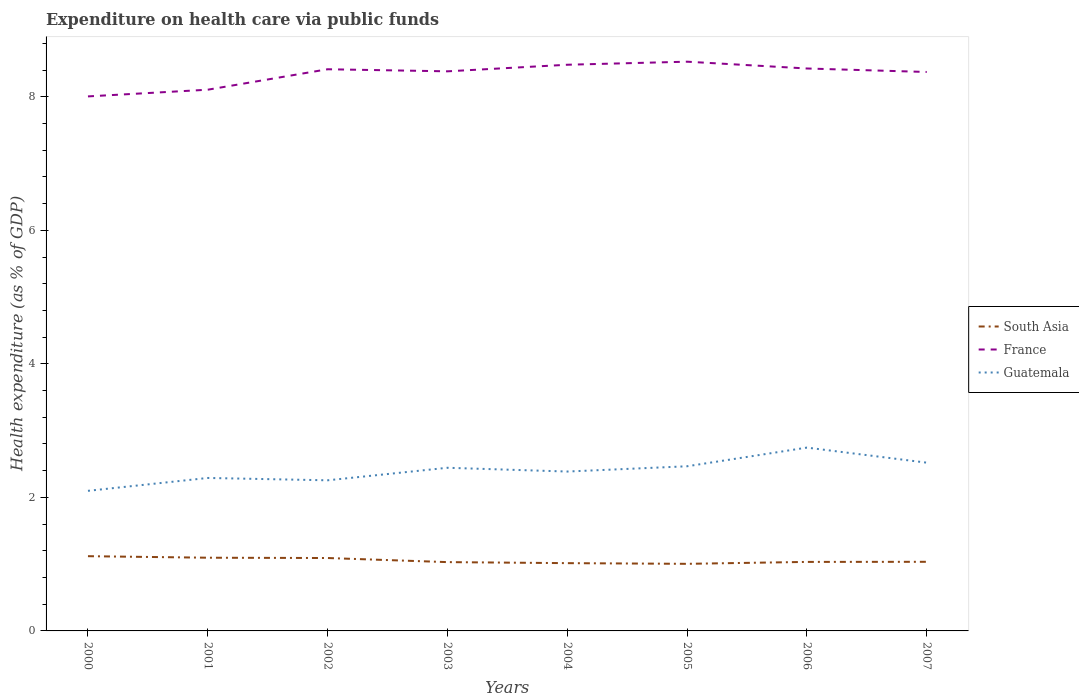How many different coloured lines are there?
Make the answer very short. 3. Is the number of lines equal to the number of legend labels?
Make the answer very short. Yes. Across all years, what is the maximum expenditure made on health care in South Asia?
Offer a terse response. 1. What is the total expenditure made on health care in South Asia in the graph?
Provide a short and direct response. 0.06. What is the difference between the highest and the second highest expenditure made on health care in South Asia?
Offer a very short reply. 0.11. What is the difference between two consecutive major ticks on the Y-axis?
Keep it short and to the point. 2. Where does the legend appear in the graph?
Give a very brief answer. Center right. What is the title of the graph?
Provide a succinct answer. Expenditure on health care via public funds. Does "Niger" appear as one of the legend labels in the graph?
Ensure brevity in your answer.  No. What is the label or title of the X-axis?
Your response must be concise. Years. What is the label or title of the Y-axis?
Your response must be concise. Health expenditure (as % of GDP). What is the Health expenditure (as % of GDP) of South Asia in 2000?
Ensure brevity in your answer.  1.12. What is the Health expenditure (as % of GDP) of France in 2000?
Make the answer very short. 8.01. What is the Health expenditure (as % of GDP) in Guatemala in 2000?
Offer a very short reply. 2.1. What is the Health expenditure (as % of GDP) of South Asia in 2001?
Provide a short and direct response. 1.1. What is the Health expenditure (as % of GDP) in France in 2001?
Your answer should be compact. 8.11. What is the Health expenditure (as % of GDP) of Guatemala in 2001?
Offer a very short reply. 2.29. What is the Health expenditure (as % of GDP) in South Asia in 2002?
Provide a succinct answer. 1.09. What is the Health expenditure (as % of GDP) of France in 2002?
Provide a short and direct response. 8.41. What is the Health expenditure (as % of GDP) of Guatemala in 2002?
Keep it short and to the point. 2.26. What is the Health expenditure (as % of GDP) of South Asia in 2003?
Your answer should be very brief. 1.03. What is the Health expenditure (as % of GDP) of France in 2003?
Give a very brief answer. 8.38. What is the Health expenditure (as % of GDP) of Guatemala in 2003?
Offer a terse response. 2.44. What is the Health expenditure (as % of GDP) of South Asia in 2004?
Provide a short and direct response. 1.02. What is the Health expenditure (as % of GDP) of France in 2004?
Your response must be concise. 8.48. What is the Health expenditure (as % of GDP) of Guatemala in 2004?
Give a very brief answer. 2.39. What is the Health expenditure (as % of GDP) in South Asia in 2005?
Your answer should be compact. 1. What is the Health expenditure (as % of GDP) in France in 2005?
Make the answer very short. 8.53. What is the Health expenditure (as % of GDP) in Guatemala in 2005?
Keep it short and to the point. 2.47. What is the Health expenditure (as % of GDP) of South Asia in 2006?
Offer a terse response. 1.03. What is the Health expenditure (as % of GDP) in France in 2006?
Your answer should be very brief. 8.42. What is the Health expenditure (as % of GDP) of Guatemala in 2006?
Make the answer very short. 2.75. What is the Health expenditure (as % of GDP) of South Asia in 2007?
Give a very brief answer. 1.04. What is the Health expenditure (as % of GDP) in France in 2007?
Keep it short and to the point. 8.37. What is the Health expenditure (as % of GDP) in Guatemala in 2007?
Make the answer very short. 2.52. Across all years, what is the maximum Health expenditure (as % of GDP) in South Asia?
Provide a succinct answer. 1.12. Across all years, what is the maximum Health expenditure (as % of GDP) in France?
Offer a very short reply. 8.53. Across all years, what is the maximum Health expenditure (as % of GDP) of Guatemala?
Offer a very short reply. 2.75. Across all years, what is the minimum Health expenditure (as % of GDP) in South Asia?
Make the answer very short. 1. Across all years, what is the minimum Health expenditure (as % of GDP) of France?
Give a very brief answer. 8.01. Across all years, what is the minimum Health expenditure (as % of GDP) of Guatemala?
Your answer should be compact. 2.1. What is the total Health expenditure (as % of GDP) in South Asia in the graph?
Give a very brief answer. 8.43. What is the total Health expenditure (as % of GDP) of France in the graph?
Give a very brief answer. 66.71. What is the total Health expenditure (as % of GDP) in Guatemala in the graph?
Your answer should be very brief. 19.21. What is the difference between the Health expenditure (as % of GDP) of South Asia in 2000 and that in 2001?
Make the answer very short. 0.02. What is the difference between the Health expenditure (as % of GDP) in France in 2000 and that in 2001?
Offer a very short reply. -0.1. What is the difference between the Health expenditure (as % of GDP) of Guatemala in 2000 and that in 2001?
Keep it short and to the point. -0.19. What is the difference between the Health expenditure (as % of GDP) of South Asia in 2000 and that in 2002?
Offer a very short reply. 0.03. What is the difference between the Health expenditure (as % of GDP) of France in 2000 and that in 2002?
Your answer should be very brief. -0.41. What is the difference between the Health expenditure (as % of GDP) of Guatemala in 2000 and that in 2002?
Offer a very short reply. -0.16. What is the difference between the Health expenditure (as % of GDP) of South Asia in 2000 and that in 2003?
Provide a short and direct response. 0.09. What is the difference between the Health expenditure (as % of GDP) of France in 2000 and that in 2003?
Offer a very short reply. -0.38. What is the difference between the Health expenditure (as % of GDP) in Guatemala in 2000 and that in 2003?
Offer a very short reply. -0.35. What is the difference between the Health expenditure (as % of GDP) of South Asia in 2000 and that in 2004?
Make the answer very short. 0.1. What is the difference between the Health expenditure (as % of GDP) of France in 2000 and that in 2004?
Offer a terse response. -0.47. What is the difference between the Health expenditure (as % of GDP) of Guatemala in 2000 and that in 2004?
Offer a terse response. -0.29. What is the difference between the Health expenditure (as % of GDP) of South Asia in 2000 and that in 2005?
Give a very brief answer. 0.11. What is the difference between the Health expenditure (as % of GDP) in France in 2000 and that in 2005?
Provide a succinct answer. -0.52. What is the difference between the Health expenditure (as % of GDP) in Guatemala in 2000 and that in 2005?
Give a very brief answer. -0.37. What is the difference between the Health expenditure (as % of GDP) in South Asia in 2000 and that in 2006?
Your answer should be compact. 0.09. What is the difference between the Health expenditure (as % of GDP) in France in 2000 and that in 2006?
Your answer should be compact. -0.42. What is the difference between the Health expenditure (as % of GDP) in Guatemala in 2000 and that in 2006?
Offer a very short reply. -0.65. What is the difference between the Health expenditure (as % of GDP) of South Asia in 2000 and that in 2007?
Keep it short and to the point. 0.08. What is the difference between the Health expenditure (as % of GDP) of France in 2000 and that in 2007?
Your response must be concise. -0.37. What is the difference between the Health expenditure (as % of GDP) of Guatemala in 2000 and that in 2007?
Your answer should be very brief. -0.42. What is the difference between the Health expenditure (as % of GDP) in South Asia in 2001 and that in 2002?
Your answer should be compact. 0. What is the difference between the Health expenditure (as % of GDP) of France in 2001 and that in 2002?
Ensure brevity in your answer.  -0.31. What is the difference between the Health expenditure (as % of GDP) of Guatemala in 2001 and that in 2002?
Offer a very short reply. 0.04. What is the difference between the Health expenditure (as % of GDP) of South Asia in 2001 and that in 2003?
Your response must be concise. 0.07. What is the difference between the Health expenditure (as % of GDP) in France in 2001 and that in 2003?
Keep it short and to the point. -0.28. What is the difference between the Health expenditure (as % of GDP) in Guatemala in 2001 and that in 2003?
Provide a short and direct response. -0.15. What is the difference between the Health expenditure (as % of GDP) of South Asia in 2001 and that in 2004?
Your response must be concise. 0.08. What is the difference between the Health expenditure (as % of GDP) in France in 2001 and that in 2004?
Offer a very short reply. -0.37. What is the difference between the Health expenditure (as % of GDP) of Guatemala in 2001 and that in 2004?
Your answer should be very brief. -0.1. What is the difference between the Health expenditure (as % of GDP) in South Asia in 2001 and that in 2005?
Offer a terse response. 0.09. What is the difference between the Health expenditure (as % of GDP) in France in 2001 and that in 2005?
Keep it short and to the point. -0.42. What is the difference between the Health expenditure (as % of GDP) in Guatemala in 2001 and that in 2005?
Offer a terse response. -0.17. What is the difference between the Health expenditure (as % of GDP) of South Asia in 2001 and that in 2006?
Offer a very short reply. 0.06. What is the difference between the Health expenditure (as % of GDP) of France in 2001 and that in 2006?
Offer a terse response. -0.32. What is the difference between the Health expenditure (as % of GDP) in Guatemala in 2001 and that in 2006?
Provide a short and direct response. -0.45. What is the difference between the Health expenditure (as % of GDP) of South Asia in 2001 and that in 2007?
Make the answer very short. 0.06. What is the difference between the Health expenditure (as % of GDP) in France in 2001 and that in 2007?
Offer a terse response. -0.27. What is the difference between the Health expenditure (as % of GDP) of Guatemala in 2001 and that in 2007?
Your response must be concise. -0.23. What is the difference between the Health expenditure (as % of GDP) in South Asia in 2002 and that in 2003?
Offer a terse response. 0.06. What is the difference between the Health expenditure (as % of GDP) of France in 2002 and that in 2003?
Your answer should be compact. 0.03. What is the difference between the Health expenditure (as % of GDP) of Guatemala in 2002 and that in 2003?
Ensure brevity in your answer.  -0.19. What is the difference between the Health expenditure (as % of GDP) of South Asia in 2002 and that in 2004?
Make the answer very short. 0.08. What is the difference between the Health expenditure (as % of GDP) of France in 2002 and that in 2004?
Your answer should be very brief. -0.07. What is the difference between the Health expenditure (as % of GDP) of Guatemala in 2002 and that in 2004?
Keep it short and to the point. -0.13. What is the difference between the Health expenditure (as % of GDP) of South Asia in 2002 and that in 2005?
Make the answer very short. 0.09. What is the difference between the Health expenditure (as % of GDP) of France in 2002 and that in 2005?
Your answer should be very brief. -0.11. What is the difference between the Health expenditure (as % of GDP) in Guatemala in 2002 and that in 2005?
Provide a succinct answer. -0.21. What is the difference between the Health expenditure (as % of GDP) of South Asia in 2002 and that in 2006?
Your answer should be very brief. 0.06. What is the difference between the Health expenditure (as % of GDP) in France in 2002 and that in 2006?
Make the answer very short. -0.01. What is the difference between the Health expenditure (as % of GDP) in Guatemala in 2002 and that in 2006?
Keep it short and to the point. -0.49. What is the difference between the Health expenditure (as % of GDP) of South Asia in 2002 and that in 2007?
Make the answer very short. 0.06. What is the difference between the Health expenditure (as % of GDP) in France in 2002 and that in 2007?
Your response must be concise. 0.04. What is the difference between the Health expenditure (as % of GDP) in Guatemala in 2002 and that in 2007?
Provide a succinct answer. -0.26. What is the difference between the Health expenditure (as % of GDP) of South Asia in 2003 and that in 2004?
Provide a succinct answer. 0.02. What is the difference between the Health expenditure (as % of GDP) in France in 2003 and that in 2004?
Your answer should be very brief. -0.1. What is the difference between the Health expenditure (as % of GDP) of Guatemala in 2003 and that in 2004?
Your response must be concise. 0.06. What is the difference between the Health expenditure (as % of GDP) in South Asia in 2003 and that in 2005?
Your response must be concise. 0.03. What is the difference between the Health expenditure (as % of GDP) in France in 2003 and that in 2005?
Offer a very short reply. -0.14. What is the difference between the Health expenditure (as % of GDP) of Guatemala in 2003 and that in 2005?
Your answer should be very brief. -0.02. What is the difference between the Health expenditure (as % of GDP) of South Asia in 2003 and that in 2006?
Make the answer very short. -0. What is the difference between the Health expenditure (as % of GDP) in France in 2003 and that in 2006?
Provide a short and direct response. -0.04. What is the difference between the Health expenditure (as % of GDP) of Guatemala in 2003 and that in 2006?
Make the answer very short. -0.3. What is the difference between the Health expenditure (as % of GDP) in South Asia in 2003 and that in 2007?
Your answer should be compact. -0. What is the difference between the Health expenditure (as % of GDP) of France in 2003 and that in 2007?
Make the answer very short. 0.01. What is the difference between the Health expenditure (as % of GDP) of Guatemala in 2003 and that in 2007?
Your answer should be compact. -0.08. What is the difference between the Health expenditure (as % of GDP) in South Asia in 2004 and that in 2005?
Offer a terse response. 0.01. What is the difference between the Health expenditure (as % of GDP) of France in 2004 and that in 2005?
Your answer should be very brief. -0.05. What is the difference between the Health expenditure (as % of GDP) of Guatemala in 2004 and that in 2005?
Your answer should be compact. -0.08. What is the difference between the Health expenditure (as % of GDP) in South Asia in 2004 and that in 2006?
Give a very brief answer. -0.02. What is the difference between the Health expenditure (as % of GDP) in France in 2004 and that in 2006?
Offer a terse response. 0.06. What is the difference between the Health expenditure (as % of GDP) in Guatemala in 2004 and that in 2006?
Your response must be concise. -0.36. What is the difference between the Health expenditure (as % of GDP) of South Asia in 2004 and that in 2007?
Provide a short and direct response. -0.02. What is the difference between the Health expenditure (as % of GDP) of France in 2004 and that in 2007?
Your answer should be compact. 0.11. What is the difference between the Health expenditure (as % of GDP) of Guatemala in 2004 and that in 2007?
Keep it short and to the point. -0.13. What is the difference between the Health expenditure (as % of GDP) of South Asia in 2005 and that in 2006?
Offer a very short reply. -0.03. What is the difference between the Health expenditure (as % of GDP) of France in 2005 and that in 2006?
Ensure brevity in your answer.  0.1. What is the difference between the Health expenditure (as % of GDP) of Guatemala in 2005 and that in 2006?
Offer a terse response. -0.28. What is the difference between the Health expenditure (as % of GDP) in South Asia in 2005 and that in 2007?
Provide a succinct answer. -0.03. What is the difference between the Health expenditure (as % of GDP) of France in 2005 and that in 2007?
Make the answer very short. 0.15. What is the difference between the Health expenditure (as % of GDP) of Guatemala in 2005 and that in 2007?
Your response must be concise. -0.05. What is the difference between the Health expenditure (as % of GDP) of South Asia in 2006 and that in 2007?
Offer a very short reply. -0. What is the difference between the Health expenditure (as % of GDP) in France in 2006 and that in 2007?
Provide a short and direct response. 0.05. What is the difference between the Health expenditure (as % of GDP) of Guatemala in 2006 and that in 2007?
Ensure brevity in your answer.  0.23. What is the difference between the Health expenditure (as % of GDP) of South Asia in 2000 and the Health expenditure (as % of GDP) of France in 2001?
Give a very brief answer. -6.99. What is the difference between the Health expenditure (as % of GDP) of South Asia in 2000 and the Health expenditure (as % of GDP) of Guatemala in 2001?
Your answer should be compact. -1.17. What is the difference between the Health expenditure (as % of GDP) in France in 2000 and the Health expenditure (as % of GDP) in Guatemala in 2001?
Provide a short and direct response. 5.71. What is the difference between the Health expenditure (as % of GDP) in South Asia in 2000 and the Health expenditure (as % of GDP) in France in 2002?
Keep it short and to the point. -7.29. What is the difference between the Health expenditure (as % of GDP) in South Asia in 2000 and the Health expenditure (as % of GDP) in Guatemala in 2002?
Your response must be concise. -1.14. What is the difference between the Health expenditure (as % of GDP) in France in 2000 and the Health expenditure (as % of GDP) in Guatemala in 2002?
Make the answer very short. 5.75. What is the difference between the Health expenditure (as % of GDP) of South Asia in 2000 and the Health expenditure (as % of GDP) of France in 2003?
Your answer should be compact. -7.26. What is the difference between the Health expenditure (as % of GDP) of South Asia in 2000 and the Health expenditure (as % of GDP) of Guatemala in 2003?
Provide a succinct answer. -1.32. What is the difference between the Health expenditure (as % of GDP) in France in 2000 and the Health expenditure (as % of GDP) in Guatemala in 2003?
Make the answer very short. 5.56. What is the difference between the Health expenditure (as % of GDP) in South Asia in 2000 and the Health expenditure (as % of GDP) in France in 2004?
Your answer should be very brief. -7.36. What is the difference between the Health expenditure (as % of GDP) of South Asia in 2000 and the Health expenditure (as % of GDP) of Guatemala in 2004?
Offer a terse response. -1.27. What is the difference between the Health expenditure (as % of GDP) in France in 2000 and the Health expenditure (as % of GDP) in Guatemala in 2004?
Keep it short and to the point. 5.62. What is the difference between the Health expenditure (as % of GDP) in South Asia in 2000 and the Health expenditure (as % of GDP) in France in 2005?
Offer a very short reply. -7.41. What is the difference between the Health expenditure (as % of GDP) in South Asia in 2000 and the Health expenditure (as % of GDP) in Guatemala in 2005?
Provide a short and direct response. -1.35. What is the difference between the Health expenditure (as % of GDP) in France in 2000 and the Health expenditure (as % of GDP) in Guatemala in 2005?
Your answer should be very brief. 5.54. What is the difference between the Health expenditure (as % of GDP) of South Asia in 2000 and the Health expenditure (as % of GDP) of France in 2006?
Offer a terse response. -7.3. What is the difference between the Health expenditure (as % of GDP) of South Asia in 2000 and the Health expenditure (as % of GDP) of Guatemala in 2006?
Keep it short and to the point. -1.63. What is the difference between the Health expenditure (as % of GDP) of France in 2000 and the Health expenditure (as % of GDP) of Guatemala in 2006?
Your answer should be compact. 5.26. What is the difference between the Health expenditure (as % of GDP) in South Asia in 2000 and the Health expenditure (as % of GDP) in France in 2007?
Your answer should be compact. -7.25. What is the difference between the Health expenditure (as % of GDP) in South Asia in 2000 and the Health expenditure (as % of GDP) in Guatemala in 2007?
Make the answer very short. -1.4. What is the difference between the Health expenditure (as % of GDP) of France in 2000 and the Health expenditure (as % of GDP) of Guatemala in 2007?
Provide a succinct answer. 5.49. What is the difference between the Health expenditure (as % of GDP) in South Asia in 2001 and the Health expenditure (as % of GDP) in France in 2002?
Keep it short and to the point. -7.32. What is the difference between the Health expenditure (as % of GDP) in South Asia in 2001 and the Health expenditure (as % of GDP) in Guatemala in 2002?
Offer a very short reply. -1.16. What is the difference between the Health expenditure (as % of GDP) in France in 2001 and the Health expenditure (as % of GDP) in Guatemala in 2002?
Your answer should be compact. 5.85. What is the difference between the Health expenditure (as % of GDP) of South Asia in 2001 and the Health expenditure (as % of GDP) of France in 2003?
Your response must be concise. -7.28. What is the difference between the Health expenditure (as % of GDP) of South Asia in 2001 and the Health expenditure (as % of GDP) of Guatemala in 2003?
Offer a very short reply. -1.35. What is the difference between the Health expenditure (as % of GDP) in France in 2001 and the Health expenditure (as % of GDP) in Guatemala in 2003?
Make the answer very short. 5.66. What is the difference between the Health expenditure (as % of GDP) of South Asia in 2001 and the Health expenditure (as % of GDP) of France in 2004?
Offer a terse response. -7.38. What is the difference between the Health expenditure (as % of GDP) of South Asia in 2001 and the Health expenditure (as % of GDP) of Guatemala in 2004?
Your response must be concise. -1.29. What is the difference between the Health expenditure (as % of GDP) of France in 2001 and the Health expenditure (as % of GDP) of Guatemala in 2004?
Your answer should be compact. 5.72. What is the difference between the Health expenditure (as % of GDP) in South Asia in 2001 and the Health expenditure (as % of GDP) in France in 2005?
Ensure brevity in your answer.  -7.43. What is the difference between the Health expenditure (as % of GDP) of South Asia in 2001 and the Health expenditure (as % of GDP) of Guatemala in 2005?
Your answer should be very brief. -1.37. What is the difference between the Health expenditure (as % of GDP) in France in 2001 and the Health expenditure (as % of GDP) in Guatemala in 2005?
Offer a very short reply. 5.64. What is the difference between the Health expenditure (as % of GDP) of South Asia in 2001 and the Health expenditure (as % of GDP) of France in 2006?
Your answer should be compact. -7.33. What is the difference between the Health expenditure (as % of GDP) of South Asia in 2001 and the Health expenditure (as % of GDP) of Guatemala in 2006?
Offer a very short reply. -1.65. What is the difference between the Health expenditure (as % of GDP) of France in 2001 and the Health expenditure (as % of GDP) of Guatemala in 2006?
Make the answer very short. 5.36. What is the difference between the Health expenditure (as % of GDP) of South Asia in 2001 and the Health expenditure (as % of GDP) of France in 2007?
Your answer should be compact. -7.28. What is the difference between the Health expenditure (as % of GDP) of South Asia in 2001 and the Health expenditure (as % of GDP) of Guatemala in 2007?
Your answer should be compact. -1.42. What is the difference between the Health expenditure (as % of GDP) in France in 2001 and the Health expenditure (as % of GDP) in Guatemala in 2007?
Offer a terse response. 5.59. What is the difference between the Health expenditure (as % of GDP) of South Asia in 2002 and the Health expenditure (as % of GDP) of France in 2003?
Provide a short and direct response. -7.29. What is the difference between the Health expenditure (as % of GDP) of South Asia in 2002 and the Health expenditure (as % of GDP) of Guatemala in 2003?
Your answer should be compact. -1.35. What is the difference between the Health expenditure (as % of GDP) of France in 2002 and the Health expenditure (as % of GDP) of Guatemala in 2003?
Offer a terse response. 5.97. What is the difference between the Health expenditure (as % of GDP) of South Asia in 2002 and the Health expenditure (as % of GDP) of France in 2004?
Offer a very short reply. -7.39. What is the difference between the Health expenditure (as % of GDP) of South Asia in 2002 and the Health expenditure (as % of GDP) of Guatemala in 2004?
Make the answer very short. -1.3. What is the difference between the Health expenditure (as % of GDP) in France in 2002 and the Health expenditure (as % of GDP) in Guatemala in 2004?
Provide a short and direct response. 6.03. What is the difference between the Health expenditure (as % of GDP) in South Asia in 2002 and the Health expenditure (as % of GDP) in France in 2005?
Your response must be concise. -7.43. What is the difference between the Health expenditure (as % of GDP) of South Asia in 2002 and the Health expenditure (as % of GDP) of Guatemala in 2005?
Ensure brevity in your answer.  -1.37. What is the difference between the Health expenditure (as % of GDP) of France in 2002 and the Health expenditure (as % of GDP) of Guatemala in 2005?
Give a very brief answer. 5.95. What is the difference between the Health expenditure (as % of GDP) in South Asia in 2002 and the Health expenditure (as % of GDP) in France in 2006?
Provide a short and direct response. -7.33. What is the difference between the Health expenditure (as % of GDP) in South Asia in 2002 and the Health expenditure (as % of GDP) in Guatemala in 2006?
Your answer should be compact. -1.65. What is the difference between the Health expenditure (as % of GDP) in France in 2002 and the Health expenditure (as % of GDP) in Guatemala in 2006?
Provide a succinct answer. 5.67. What is the difference between the Health expenditure (as % of GDP) in South Asia in 2002 and the Health expenditure (as % of GDP) in France in 2007?
Your answer should be very brief. -7.28. What is the difference between the Health expenditure (as % of GDP) of South Asia in 2002 and the Health expenditure (as % of GDP) of Guatemala in 2007?
Your answer should be compact. -1.43. What is the difference between the Health expenditure (as % of GDP) of France in 2002 and the Health expenditure (as % of GDP) of Guatemala in 2007?
Give a very brief answer. 5.89. What is the difference between the Health expenditure (as % of GDP) of South Asia in 2003 and the Health expenditure (as % of GDP) of France in 2004?
Offer a terse response. -7.45. What is the difference between the Health expenditure (as % of GDP) of South Asia in 2003 and the Health expenditure (as % of GDP) of Guatemala in 2004?
Ensure brevity in your answer.  -1.36. What is the difference between the Health expenditure (as % of GDP) in France in 2003 and the Health expenditure (as % of GDP) in Guatemala in 2004?
Offer a terse response. 5.99. What is the difference between the Health expenditure (as % of GDP) in South Asia in 2003 and the Health expenditure (as % of GDP) in France in 2005?
Your answer should be very brief. -7.5. What is the difference between the Health expenditure (as % of GDP) in South Asia in 2003 and the Health expenditure (as % of GDP) in Guatemala in 2005?
Your answer should be very brief. -1.44. What is the difference between the Health expenditure (as % of GDP) of France in 2003 and the Health expenditure (as % of GDP) of Guatemala in 2005?
Ensure brevity in your answer.  5.92. What is the difference between the Health expenditure (as % of GDP) in South Asia in 2003 and the Health expenditure (as % of GDP) in France in 2006?
Your answer should be very brief. -7.39. What is the difference between the Health expenditure (as % of GDP) in South Asia in 2003 and the Health expenditure (as % of GDP) in Guatemala in 2006?
Keep it short and to the point. -1.72. What is the difference between the Health expenditure (as % of GDP) in France in 2003 and the Health expenditure (as % of GDP) in Guatemala in 2006?
Make the answer very short. 5.64. What is the difference between the Health expenditure (as % of GDP) in South Asia in 2003 and the Health expenditure (as % of GDP) in France in 2007?
Your answer should be compact. -7.34. What is the difference between the Health expenditure (as % of GDP) of South Asia in 2003 and the Health expenditure (as % of GDP) of Guatemala in 2007?
Your response must be concise. -1.49. What is the difference between the Health expenditure (as % of GDP) of France in 2003 and the Health expenditure (as % of GDP) of Guatemala in 2007?
Offer a very short reply. 5.86. What is the difference between the Health expenditure (as % of GDP) of South Asia in 2004 and the Health expenditure (as % of GDP) of France in 2005?
Give a very brief answer. -7.51. What is the difference between the Health expenditure (as % of GDP) of South Asia in 2004 and the Health expenditure (as % of GDP) of Guatemala in 2005?
Ensure brevity in your answer.  -1.45. What is the difference between the Health expenditure (as % of GDP) in France in 2004 and the Health expenditure (as % of GDP) in Guatemala in 2005?
Provide a succinct answer. 6.01. What is the difference between the Health expenditure (as % of GDP) in South Asia in 2004 and the Health expenditure (as % of GDP) in France in 2006?
Your response must be concise. -7.41. What is the difference between the Health expenditure (as % of GDP) of South Asia in 2004 and the Health expenditure (as % of GDP) of Guatemala in 2006?
Your response must be concise. -1.73. What is the difference between the Health expenditure (as % of GDP) of France in 2004 and the Health expenditure (as % of GDP) of Guatemala in 2006?
Ensure brevity in your answer.  5.73. What is the difference between the Health expenditure (as % of GDP) of South Asia in 2004 and the Health expenditure (as % of GDP) of France in 2007?
Your answer should be very brief. -7.36. What is the difference between the Health expenditure (as % of GDP) in South Asia in 2004 and the Health expenditure (as % of GDP) in Guatemala in 2007?
Your answer should be compact. -1.5. What is the difference between the Health expenditure (as % of GDP) of France in 2004 and the Health expenditure (as % of GDP) of Guatemala in 2007?
Your answer should be very brief. 5.96. What is the difference between the Health expenditure (as % of GDP) in South Asia in 2005 and the Health expenditure (as % of GDP) in France in 2006?
Give a very brief answer. -7.42. What is the difference between the Health expenditure (as % of GDP) in South Asia in 2005 and the Health expenditure (as % of GDP) in Guatemala in 2006?
Keep it short and to the point. -1.74. What is the difference between the Health expenditure (as % of GDP) in France in 2005 and the Health expenditure (as % of GDP) in Guatemala in 2006?
Provide a short and direct response. 5.78. What is the difference between the Health expenditure (as % of GDP) of South Asia in 2005 and the Health expenditure (as % of GDP) of France in 2007?
Your response must be concise. -7.37. What is the difference between the Health expenditure (as % of GDP) of South Asia in 2005 and the Health expenditure (as % of GDP) of Guatemala in 2007?
Your answer should be compact. -1.52. What is the difference between the Health expenditure (as % of GDP) in France in 2005 and the Health expenditure (as % of GDP) in Guatemala in 2007?
Ensure brevity in your answer.  6.01. What is the difference between the Health expenditure (as % of GDP) of South Asia in 2006 and the Health expenditure (as % of GDP) of France in 2007?
Offer a very short reply. -7.34. What is the difference between the Health expenditure (as % of GDP) of South Asia in 2006 and the Health expenditure (as % of GDP) of Guatemala in 2007?
Give a very brief answer. -1.49. What is the difference between the Health expenditure (as % of GDP) of France in 2006 and the Health expenditure (as % of GDP) of Guatemala in 2007?
Offer a very short reply. 5.9. What is the average Health expenditure (as % of GDP) of South Asia per year?
Ensure brevity in your answer.  1.05. What is the average Health expenditure (as % of GDP) of France per year?
Give a very brief answer. 8.34. What is the average Health expenditure (as % of GDP) in Guatemala per year?
Offer a terse response. 2.4. In the year 2000, what is the difference between the Health expenditure (as % of GDP) in South Asia and Health expenditure (as % of GDP) in France?
Make the answer very short. -6.89. In the year 2000, what is the difference between the Health expenditure (as % of GDP) in South Asia and Health expenditure (as % of GDP) in Guatemala?
Keep it short and to the point. -0.98. In the year 2000, what is the difference between the Health expenditure (as % of GDP) in France and Health expenditure (as % of GDP) in Guatemala?
Make the answer very short. 5.91. In the year 2001, what is the difference between the Health expenditure (as % of GDP) of South Asia and Health expenditure (as % of GDP) of France?
Provide a succinct answer. -7.01. In the year 2001, what is the difference between the Health expenditure (as % of GDP) in South Asia and Health expenditure (as % of GDP) in Guatemala?
Provide a succinct answer. -1.19. In the year 2001, what is the difference between the Health expenditure (as % of GDP) in France and Health expenditure (as % of GDP) in Guatemala?
Your response must be concise. 5.82. In the year 2002, what is the difference between the Health expenditure (as % of GDP) in South Asia and Health expenditure (as % of GDP) in France?
Your response must be concise. -7.32. In the year 2002, what is the difference between the Health expenditure (as % of GDP) of South Asia and Health expenditure (as % of GDP) of Guatemala?
Your answer should be very brief. -1.16. In the year 2002, what is the difference between the Health expenditure (as % of GDP) of France and Health expenditure (as % of GDP) of Guatemala?
Your response must be concise. 6.16. In the year 2003, what is the difference between the Health expenditure (as % of GDP) in South Asia and Health expenditure (as % of GDP) in France?
Provide a succinct answer. -7.35. In the year 2003, what is the difference between the Health expenditure (as % of GDP) in South Asia and Health expenditure (as % of GDP) in Guatemala?
Offer a terse response. -1.41. In the year 2003, what is the difference between the Health expenditure (as % of GDP) of France and Health expenditure (as % of GDP) of Guatemala?
Make the answer very short. 5.94. In the year 2004, what is the difference between the Health expenditure (as % of GDP) of South Asia and Health expenditure (as % of GDP) of France?
Your answer should be very brief. -7.46. In the year 2004, what is the difference between the Health expenditure (as % of GDP) of South Asia and Health expenditure (as % of GDP) of Guatemala?
Offer a terse response. -1.37. In the year 2004, what is the difference between the Health expenditure (as % of GDP) of France and Health expenditure (as % of GDP) of Guatemala?
Your answer should be very brief. 6.09. In the year 2005, what is the difference between the Health expenditure (as % of GDP) in South Asia and Health expenditure (as % of GDP) in France?
Give a very brief answer. -7.52. In the year 2005, what is the difference between the Health expenditure (as % of GDP) of South Asia and Health expenditure (as % of GDP) of Guatemala?
Keep it short and to the point. -1.46. In the year 2005, what is the difference between the Health expenditure (as % of GDP) in France and Health expenditure (as % of GDP) in Guatemala?
Keep it short and to the point. 6.06. In the year 2006, what is the difference between the Health expenditure (as % of GDP) of South Asia and Health expenditure (as % of GDP) of France?
Offer a very short reply. -7.39. In the year 2006, what is the difference between the Health expenditure (as % of GDP) in South Asia and Health expenditure (as % of GDP) in Guatemala?
Make the answer very short. -1.71. In the year 2006, what is the difference between the Health expenditure (as % of GDP) of France and Health expenditure (as % of GDP) of Guatemala?
Your answer should be very brief. 5.68. In the year 2007, what is the difference between the Health expenditure (as % of GDP) of South Asia and Health expenditure (as % of GDP) of France?
Give a very brief answer. -7.34. In the year 2007, what is the difference between the Health expenditure (as % of GDP) of South Asia and Health expenditure (as % of GDP) of Guatemala?
Your answer should be very brief. -1.48. In the year 2007, what is the difference between the Health expenditure (as % of GDP) of France and Health expenditure (as % of GDP) of Guatemala?
Your answer should be very brief. 5.85. What is the ratio of the Health expenditure (as % of GDP) of South Asia in 2000 to that in 2001?
Offer a very short reply. 1.02. What is the ratio of the Health expenditure (as % of GDP) in France in 2000 to that in 2001?
Provide a succinct answer. 0.99. What is the ratio of the Health expenditure (as % of GDP) in Guatemala in 2000 to that in 2001?
Offer a very short reply. 0.92. What is the ratio of the Health expenditure (as % of GDP) of South Asia in 2000 to that in 2002?
Your answer should be very brief. 1.03. What is the ratio of the Health expenditure (as % of GDP) in France in 2000 to that in 2002?
Your answer should be compact. 0.95. What is the ratio of the Health expenditure (as % of GDP) of Guatemala in 2000 to that in 2002?
Give a very brief answer. 0.93. What is the ratio of the Health expenditure (as % of GDP) of South Asia in 2000 to that in 2003?
Give a very brief answer. 1.09. What is the ratio of the Health expenditure (as % of GDP) of France in 2000 to that in 2003?
Your answer should be very brief. 0.96. What is the ratio of the Health expenditure (as % of GDP) in Guatemala in 2000 to that in 2003?
Make the answer very short. 0.86. What is the ratio of the Health expenditure (as % of GDP) in South Asia in 2000 to that in 2004?
Your answer should be very brief. 1.1. What is the ratio of the Health expenditure (as % of GDP) in France in 2000 to that in 2004?
Your answer should be compact. 0.94. What is the ratio of the Health expenditure (as % of GDP) of Guatemala in 2000 to that in 2004?
Your answer should be compact. 0.88. What is the ratio of the Health expenditure (as % of GDP) in South Asia in 2000 to that in 2005?
Give a very brief answer. 1.11. What is the ratio of the Health expenditure (as % of GDP) of France in 2000 to that in 2005?
Your answer should be compact. 0.94. What is the ratio of the Health expenditure (as % of GDP) of Guatemala in 2000 to that in 2005?
Your response must be concise. 0.85. What is the ratio of the Health expenditure (as % of GDP) of South Asia in 2000 to that in 2006?
Your answer should be compact. 1.08. What is the ratio of the Health expenditure (as % of GDP) of France in 2000 to that in 2006?
Keep it short and to the point. 0.95. What is the ratio of the Health expenditure (as % of GDP) of Guatemala in 2000 to that in 2006?
Offer a terse response. 0.76. What is the ratio of the Health expenditure (as % of GDP) in South Asia in 2000 to that in 2007?
Offer a terse response. 1.08. What is the ratio of the Health expenditure (as % of GDP) of France in 2000 to that in 2007?
Keep it short and to the point. 0.96. What is the ratio of the Health expenditure (as % of GDP) of Guatemala in 2000 to that in 2007?
Keep it short and to the point. 0.83. What is the ratio of the Health expenditure (as % of GDP) in France in 2001 to that in 2002?
Offer a very short reply. 0.96. What is the ratio of the Health expenditure (as % of GDP) in Guatemala in 2001 to that in 2002?
Provide a short and direct response. 1.02. What is the ratio of the Health expenditure (as % of GDP) of South Asia in 2001 to that in 2003?
Offer a very short reply. 1.06. What is the ratio of the Health expenditure (as % of GDP) of France in 2001 to that in 2003?
Ensure brevity in your answer.  0.97. What is the ratio of the Health expenditure (as % of GDP) in Guatemala in 2001 to that in 2003?
Ensure brevity in your answer.  0.94. What is the ratio of the Health expenditure (as % of GDP) in South Asia in 2001 to that in 2004?
Offer a very short reply. 1.08. What is the ratio of the Health expenditure (as % of GDP) in France in 2001 to that in 2004?
Ensure brevity in your answer.  0.96. What is the ratio of the Health expenditure (as % of GDP) in Guatemala in 2001 to that in 2004?
Provide a short and direct response. 0.96. What is the ratio of the Health expenditure (as % of GDP) in South Asia in 2001 to that in 2005?
Give a very brief answer. 1.09. What is the ratio of the Health expenditure (as % of GDP) in France in 2001 to that in 2005?
Provide a succinct answer. 0.95. What is the ratio of the Health expenditure (as % of GDP) of Guatemala in 2001 to that in 2005?
Give a very brief answer. 0.93. What is the ratio of the Health expenditure (as % of GDP) in South Asia in 2001 to that in 2006?
Offer a terse response. 1.06. What is the ratio of the Health expenditure (as % of GDP) of France in 2001 to that in 2006?
Your answer should be compact. 0.96. What is the ratio of the Health expenditure (as % of GDP) of Guatemala in 2001 to that in 2006?
Offer a terse response. 0.83. What is the ratio of the Health expenditure (as % of GDP) in South Asia in 2001 to that in 2007?
Ensure brevity in your answer.  1.06. What is the ratio of the Health expenditure (as % of GDP) in France in 2001 to that in 2007?
Keep it short and to the point. 0.97. What is the ratio of the Health expenditure (as % of GDP) in South Asia in 2002 to that in 2003?
Provide a short and direct response. 1.06. What is the ratio of the Health expenditure (as % of GDP) in Guatemala in 2002 to that in 2003?
Keep it short and to the point. 0.92. What is the ratio of the Health expenditure (as % of GDP) in South Asia in 2002 to that in 2004?
Your answer should be very brief. 1.08. What is the ratio of the Health expenditure (as % of GDP) of France in 2002 to that in 2004?
Provide a succinct answer. 0.99. What is the ratio of the Health expenditure (as % of GDP) of Guatemala in 2002 to that in 2004?
Offer a terse response. 0.94. What is the ratio of the Health expenditure (as % of GDP) of South Asia in 2002 to that in 2005?
Give a very brief answer. 1.09. What is the ratio of the Health expenditure (as % of GDP) in France in 2002 to that in 2005?
Ensure brevity in your answer.  0.99. What is the ratio of the Health expenditure (as % of GDP) in Guatemala in 2002 to that in 2005?
Your answer should be very brief. 0.91. What is the ratio of the Health expenditure (as % of GDP) in South Asia in 2002 to that in 2006?
Keep it short and to the point. 1.06. What is the ratio of the Health expenditure (as % of GDP) in France in 2002 to that in 2006?
Provide a succinct answer. 1. What is the ratio of the Health expenditure (as % of GDP) of Guatemala in 2002 to that in 2006?
Keep it short and to the point. 0.82. What is the ratio of the Health expenditure (as % of GDP) in South Asia in 2002 to that in 2007?
Keep it short and to the point. 1.05. What is the ratio of the Health expenditure (as % of GDP) in Guatemala in 2002 to that in 2007?
Provide a succinct answer. 0.9. What is the ratio of the Health expenditure (as % of GDP) in South Asia in 2003 to that in 2004?
Ensure brevity in your answer.  1.02. What is the ratio of the Health expenditure (as % of GDP) in France in 2003 to that in 2004?
Provide a succinct answer. 0.99. What is the ratio of the Health expenditure (as % of GDP) of Guatemala in 2003 to that in 2004?
Give a very brief answer. 1.02. What is the ratio of the Health expenditure (as % of GDP) in South Asia in 2003 to that in 2005?
Your answer should be compact. 1.03. What is the ratio of the Health expenditure (as % of GDP) of France in 2003 to that in 2005?
Your answer should be very brief. 0.98. What is the ratio of the Health expenditure (as % of GDP) in Guatemala in 2003 to that in 2005?
Provide a short and direct response. 0.99. What is the ratio of the Health expenditure (as % of GDP) in South Asia in 2003 to that in 2006?
Keep it short and to the point. 1. What is the ratio of the Health expenditure (as % of GDP) of France in 2003 to that in 2006?
Offer a very short reply. 0.99. What is the ratio of the Health expenditure (as % of GDP) of Guatemala in 2003 to that in 2006?
Provide a succinct answer. 0.89. What is the ratio of the Health expenditure (as % of GDP) in France in 2003 to that in 2007?
Provide a succinct answer. 1. What is the ratio of the Health expenditure (as % of GDP) of Guatemala in 2003 to that in 2007?
Ensure brevity in your answer.  0.97. What is the ratio of the Health expenditure (as % of GDP) in South Asia in 2004 to that in 2005?
Give a very brief answer. 1.01. What is the ratio of the Health expenditure (as % of GDP) in Guatemala in 2004 to that in 2005?
Provide a succinct answer. 0.97. What is the ratio of the Health expenditure (as % of GDP) in South Asia in 2004 to that in 2006?
Provide a succinct answer. 0.98. What is the ratio of the Health expenditure (as % of GDP) in Guatemala in 2004 to that in 2006?
Offer a very short reply. 0.87. What is the ratio of the Health expenditure (as % of GDP) of South Asia in 2004 to that in 2007?
Your answer should be very brief. 0.98. What is the ratio of the Health expenditure (as % of GDP) of France in 2004 to that in 2007?
Keep it short and to the point. 1.01. What is the ratio of the Health expenditure (as % of GDP) in Guatemala in 2004 to that in 2007?
Ensure brevity in your answer.  0.95. What is the ratio of the Health expenditure (as % of GDP) in South Asia in 2005 to that in 2006?
Offer a terse response. 0.97. What is the ratio of the Health expenditure (as % of GDP) of France in 2005 to that in 2006?
Provide a succinct answer. 1.01. What is the ratio of the Health expenditure (as % of GDP) of Guatemala in 2005 to that in 2006?
Your answer should be very brief. 0.9. What is the ratio of the Health expenditure (as % of GDP) of South Asia in 2005 to that in 2007?
Give a very brief answer. 0.97. What is the ratio of the Health expenditure (as % of GDP) in France in 2005 to that in 2007?
Make the answer very short. 1.02. What is the ratio of the Health expenditure (as % of GDP) of Guatemala in 2005 to that in 2007?
Provide a short and direct response. 0.98. What is the ratio of the Health expenditure (as % of GDP) of South Asia in 2006 to that in 2007?
Make the answer very short. 1. What is the ratio of the Health expenditure (as % of GDP) of Guatemala in 2006 to that in 2007?
Make the answer very short. 1.09. What is the difference between the highest and the second highest Health expenditure (as % of GDP) in South Asia?
Provide a short and direct response. 0.02. What is the difference between the highest and the second highest Health expenditure (as % of GDP) in France?
Offer a terse response. 0.05. What is the difference between the highest and the second highest Health expenditure (as % of GDP) of Guatemala?
Make the answer very short. 0.23. What is the difference between the highest and the lowest Health expenditure (as % of GDP) of South Asia?
Make the answer very short. 0.11. What is the difference between the highest and the lowest Health expenditure (as % of GDP) in France?
Give a very brief answer. 0.52. What is the difference between the highest and the lowest Health expenditure (as % of GDP) of Guatemala?
Your response must be concise. 0.65. 